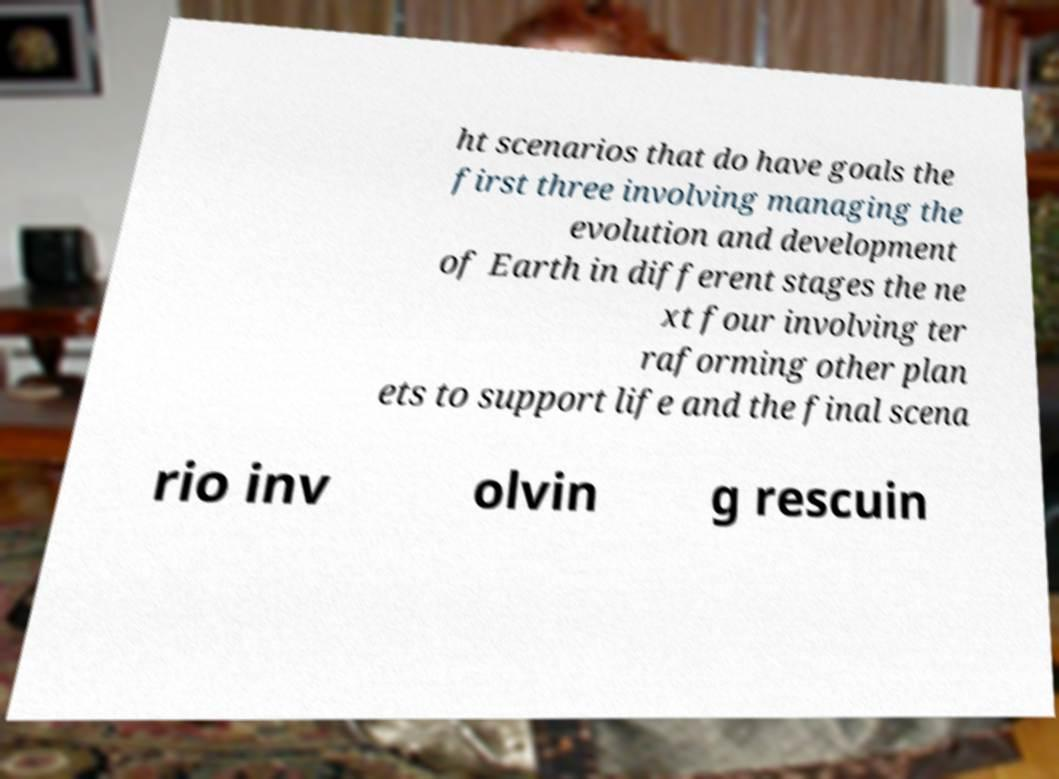Please identify and transcribe the text found in this image. ht scenarios that do have goals the first three involving managing the evolution and development of Earth in different stages the ne xt four involving ter raforming other plan ets to support life and the final scena rio inv olvin g rescuin 